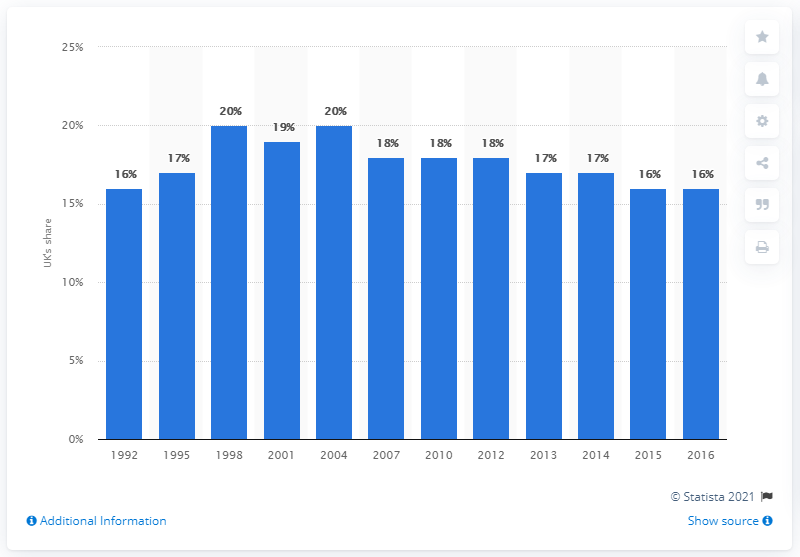Draw attention to some important aspects in this diagram. In 2004, the United Kingdom's share of international bank lending was approximately 20%. The UK's share in international bank lending 10 years later was significant. 